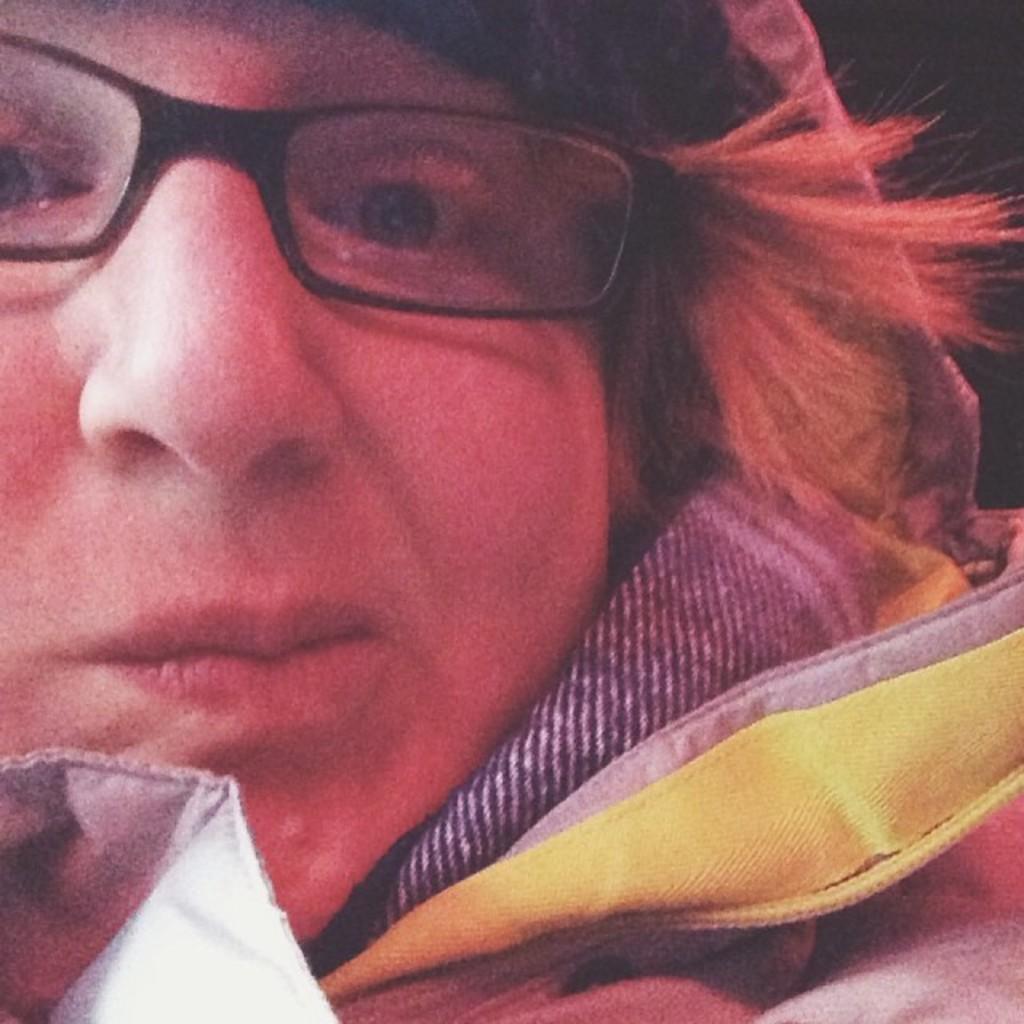In one or two sentences, can you explain what this image depicts? In this image, we can see a person wearing clothes and spectacles. 